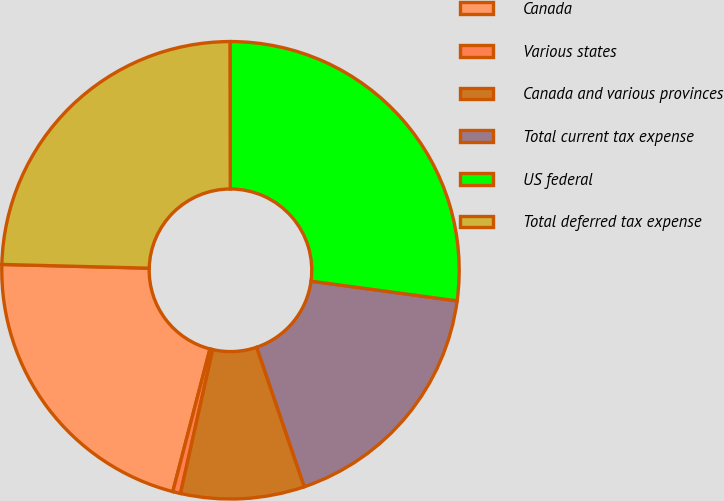<chart> <loc_0><loc_0><loc_500><loc_500><pie_chart><fcel>Canada<fcel>Various states<fcel>Canada and various provinces<fcel>Total current tax expense<fcel>US federal<fcel>Total deferred tax expense<nl><fcel>21.35%<fcel>0.55%<fcel>8.74%<fcel>17.63%<fcel>27.17%<fcel>24.56%<nl></chart> 